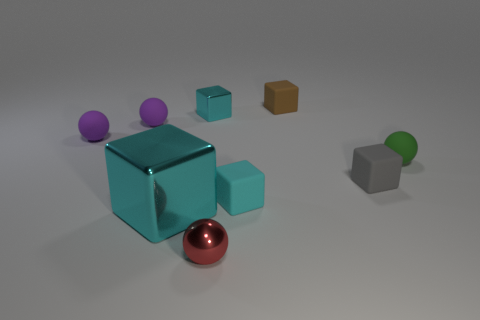How many cyan things have the same shape as the red metallic thing?
Your response must be concise. 0. There is a small thing that is the same color as the tiny shiny block; what material is it?
Offer a very short reply. Rubber. What number of rubber spheres are there?
Offer a very short reply. 3. There is a gray object; is it the same shape as the cyan thing that is on the right side of the small cyan metal thing?
Keep it short and to the point. Yes. How many things are small purple matte balls or tiny things that are behind the green rubber sphere?
Offer a very short reply. 4. There is a brown object that is the same shape as the tiny gray matte object; what material is it?
Your answer should be compact. Rubber. Do the cyan metallic thing right of the big cyan metallic thing and the large cyan shiny object have the same shape?
Make the answer very short. Yes. Are there fewer small purple spheres in front of the cyan rubber block than spheres behind the tiny metallic ball?
Your response must be concise. Yes. What number of other things are there of the same shape as the tiny green object?
Provide a succinct answer. 3. What size is the cyan thing that is in front of the tiny cyan cube that is right of the cyan metallic block behind the tiny green matte ball?
Your answer should be very brief. Large. 